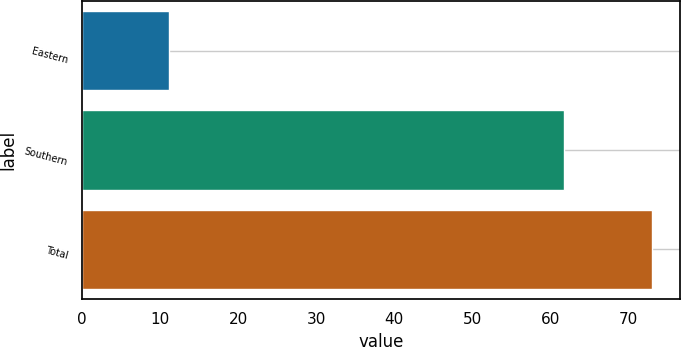Convert chart. <chart><loc_0><loc_0><loc_500><loc_500><bar_chart><fcel>Eastern<fcel>Southern<fcel>Total<nl><fcel>11.2<fcel>61.8<fcel>73<nl></chart> 